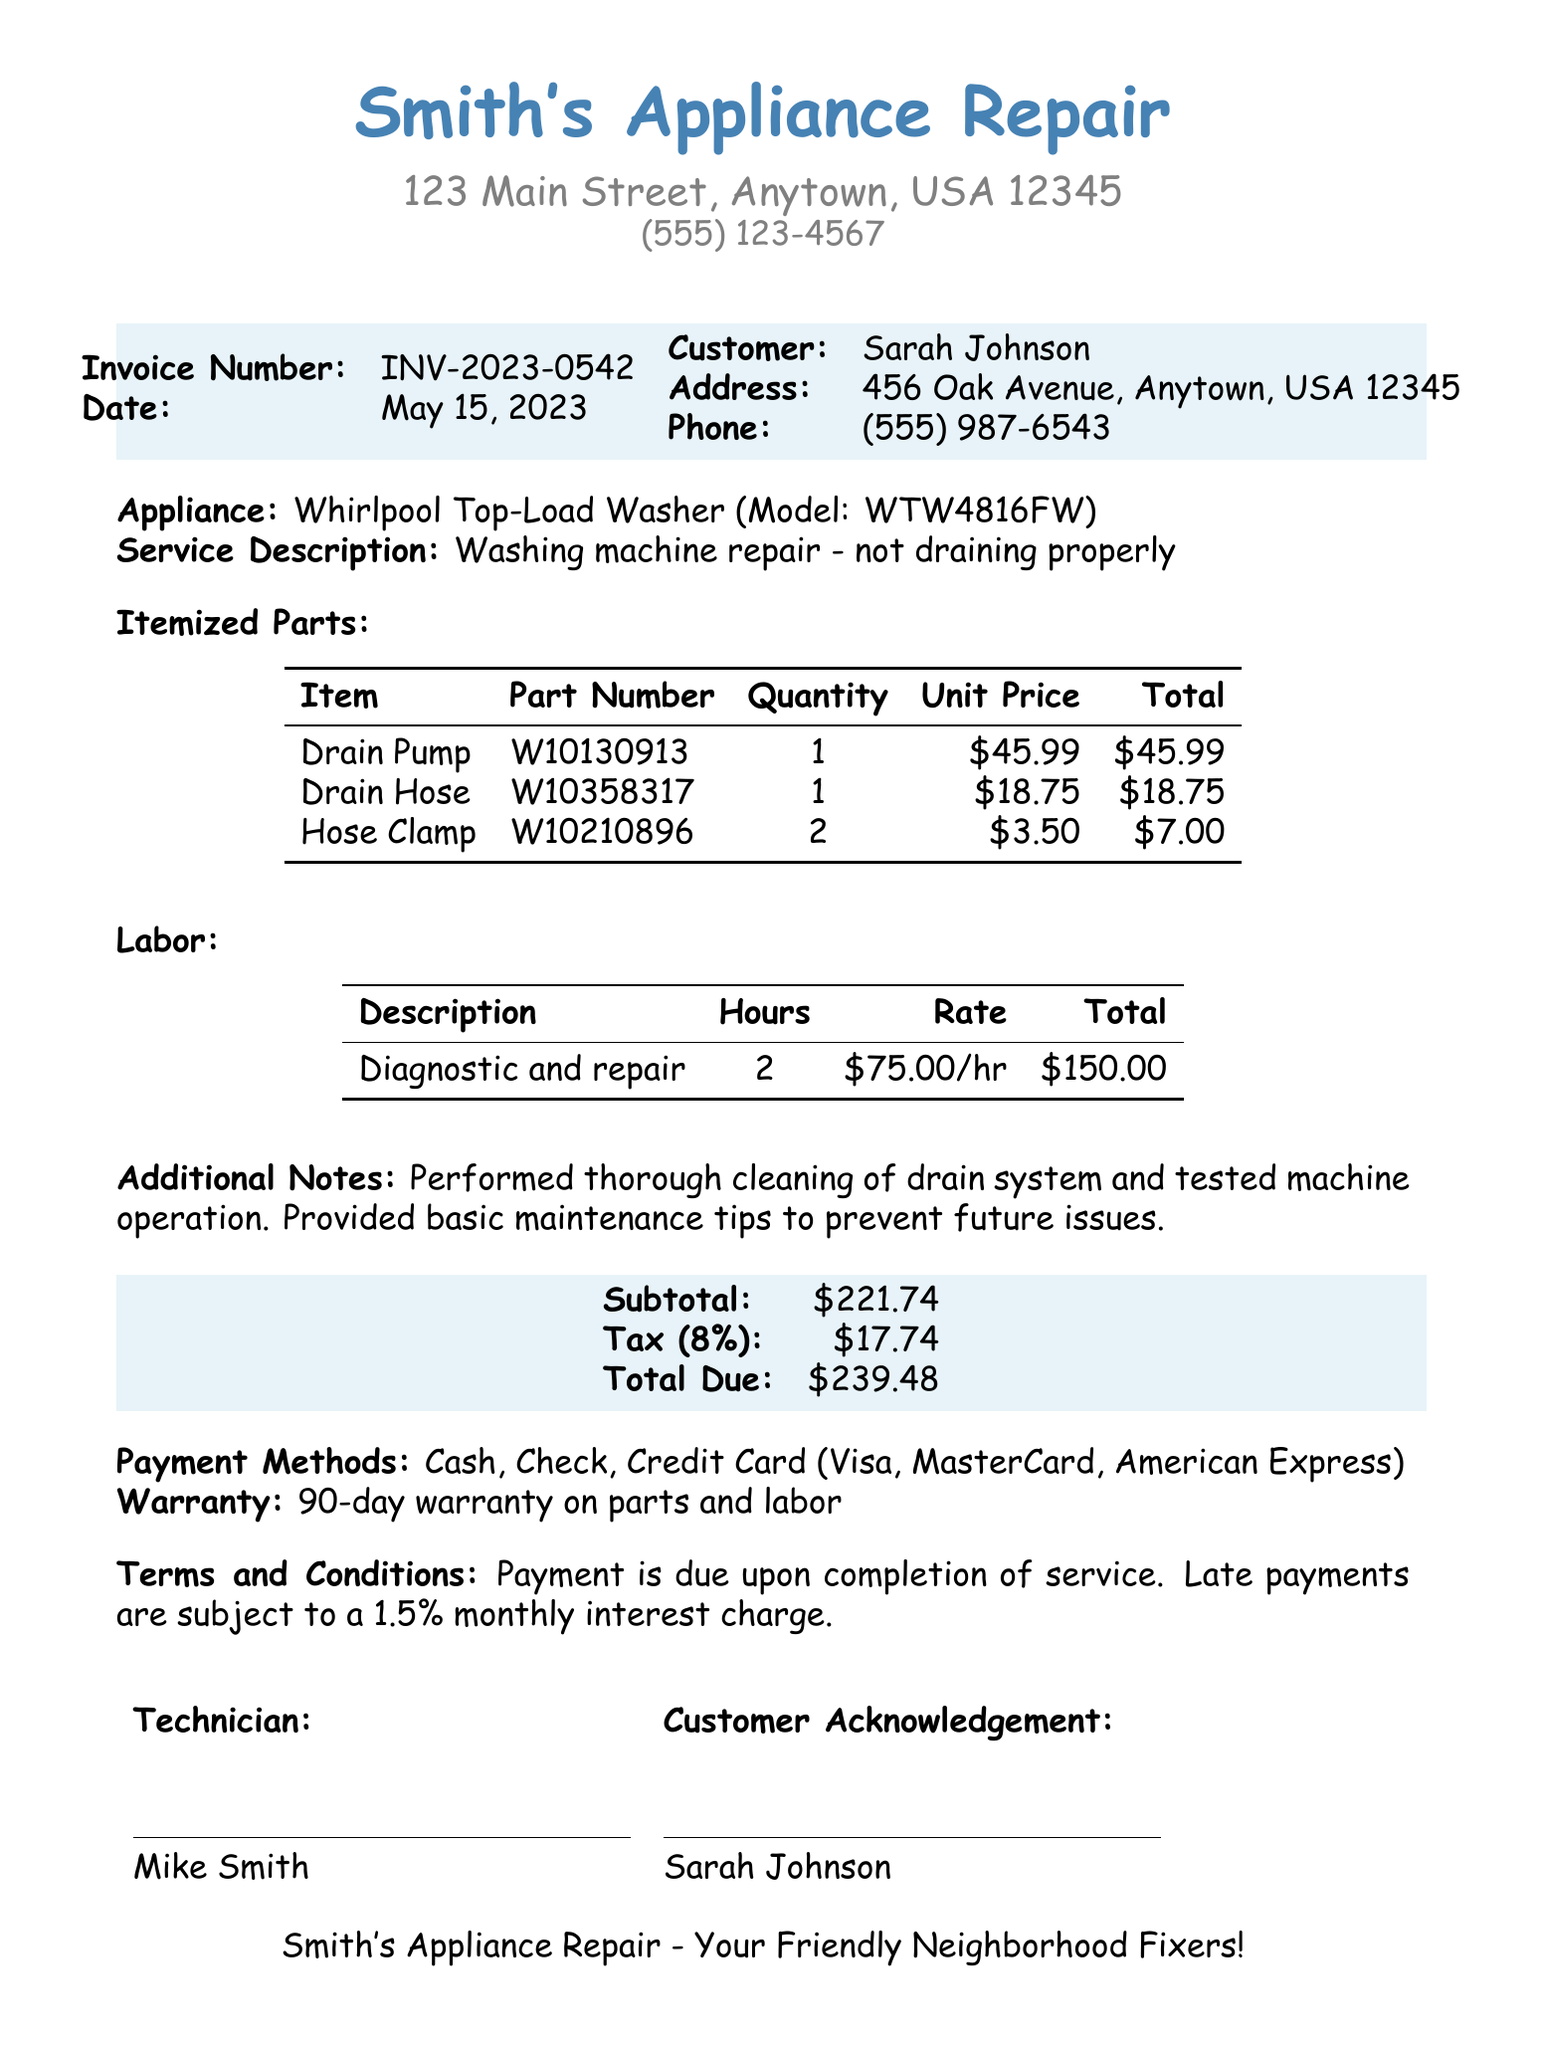What is the business name? The business name is prominently displayed at the top of the invoice.
Answer: Smith's Appliance Repair What is the invoice number? The invoice number is clearly stated in the document for reference.
Answer: INV-2023-0542 What is the total due amount? The total due amount is calculated at the bottom of the invoice summary.
Answer: $239.48 How many hours of labor were charged? The number of hours charged for labor is indicated in the labor section of the document.
Answer: 2 What is the warranty period for parts and labor? The warranty information is specified in a section towards the end of the document.
Answer: 90-day warranty What was the service description? The service description summarizes the issue addressed in this repair invoice.
Answer: Washing machine repair - not draining properly What types of payment are accepted? Accepted payment methods are listed towards the end of the invoice.
Answer: Cash, Check, Credit Card (Visa, MasterCard, American Express) Who performed the service? The technician's name is noted in the technician acknowledgment section of the invoice.
Answer: Mike Smith What is the subtotal of parts? The subtotal of parts before tax is detailed in the pricing summary section.
Answer: $221.74 